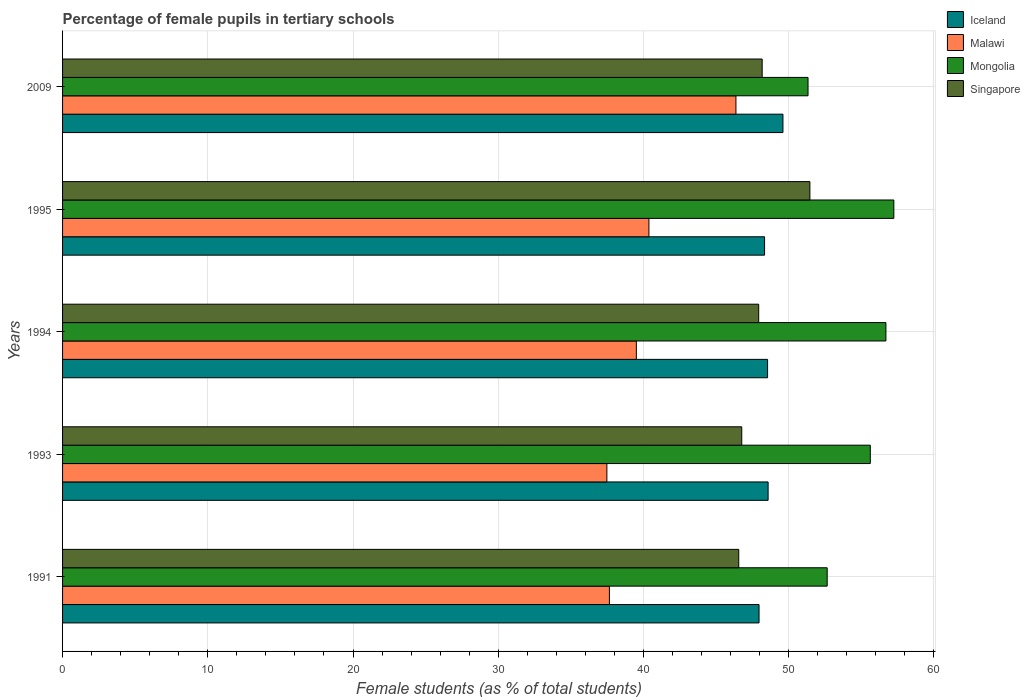How many bars are there on the 2nd tick from the top?
Provide a succinct answer. 4. What is the label of the 4th group of bars from the top?
Your response must be concise. 1993. What is the percentage of female pupils in tertiary schools in Malawi in 2009?
Make the answer very short. 46.37. Across all years, what is the maximum percentage of female pupils in tertiary schools in Mongolia?
Keep it short and to the point. 57.25. Across all years, what is the minimum percentage of female pupils in tertiary schools in Malawi?
Your response must be concise. 37.48. In which year was the percentage of female pupils in tertiary schools in Iceland minimum?
Your answer should be compact. 1991. What is the total percentage of female pupils in tertiary schools in Malawi in the graph?
Your answer should be very brief. 201.4. What is the difference between the percentage of female pupils in tertiary schools in Singapore in 1994 and that in 1995?
Your answer should be very brief. -3.53. What is the difference between the percentage of female pupils in tertiary schools in Malawi in 1994 and the percentage of female pupils in tertiary schools in Mongolia in 1993?
Give a very brief answer. -16.11. What is the average percentage of female pupils in tertiary schools in Iceland per year?
Your answer should be very brief. 48.61. In the year 1993, what is the difference between the percentage of female pupils in tertiary schools in Singapore and percentage of female pupils in tertiary schools in Iceland?
Your response must be concise. -1.81. In how many years, is the percentage of female pupils in tertiary schools in Iceland greater than 14 %?
Your answer should be compact. 5. What is the ratio of the percentage of female pupils in tertiary schools in Mongolia in 1993 to that in 1994?
Make the answer very short. 0.98. What is the difference between the highest and the second highest percentage of female pupils in tertiary schools in Iceland?
Provide a short and direct response. 1.02. What is the difference between the highest and the lowest percentage of female pupils in tertiary schools in Malawi?
Your answer should be very brief. 8.89. Is the sum of the percentage of female pupils in tertiary schools in Singapore in 1993 and 1995 greater than the maximum percentage of female pupils in tertiary schools in Iceland across all years?
Give a very brief answer. Yes. Is it the case that in every year, the sum of the percentage of female pupils in tertiary schools in Singapore and percentage of female pupils in tertiary schools in Mongolia is greater than the sum of percentage of female pupils in tertiary schools in Iceland and percentage of female pupils in tertiary schools in Malawi?
Give a very brief answer. Yes. What does the 1st bar from the top in 2009 represents?
Make the answer very short. Singapore. What does the 1st bar from the bottom in 1993 represents?
Give a very brief answer. Iceland. Is it the case that in every year, the sum of the percentage of female pupils in tertiary schools in Iceland and percentage of female pupils in tertiary schools in Mongolia is greater than the percentage of female pupils in tertiary schools in Malawi?
Make the answer very short. Yes. How many years are there in the graph?
Provide a short and direct response. 5. Does the graph contain grids?
Make the answer very short. Yes. Where does the legend appear in the graph?
Give a very brief answer. Top right. How many legend labels are there?
Make the answer very short. 4. How are the legend labels stacked?
Provide a succinct answer. Vertical. What is the title of the graph?
Your response must be concise. Percentage of female pupils in tertiary schools. What is the label or title of the X-axis?
Give a very brief answer. Female students (as % of total students). What is the Female students (as % of total students) of Iceland in 1991?
Keep it short and to the point. 47.96. What is the Female students (as % of total students) in Malawi in 1991?
Give a very brief answer. 37.66. What is the Female students (as % of total students) of Mongolia in 1991?
Your response must be concise. 52.66. What is the Female students (as % of total students) of Singapore in 1991?
Your answer should be very brief. 46.56. What is the Female students (as % of total students) in Iceland in 1993?
Keep it short and to the point. 48.59. What is the Female students (as % of total students) in Malawi in 1993?
Ensure brevity in your answer.  37.48. What is the Female students (as % of total students) in Mongolia in 1993?
Make the answer very short. 55.62. What is the Female students (as % of total students) of Singapore in 1993?
Your answer should be compact. 46.77. What is the Female students (as % of total students) in Iceland in 1994?
Give a very brief answer. 48.55. What is the Female students (as % of total students) in Malawi in 1994?
Keep it short and to the point. 39.51. What is the Female students (as % of total students) of Mongolia in 1994?
Offer a terse response. 56.7. What is the Female students (as % of total students) of Singapore in 1994?
Make the answer very short. 47.94. What is the Female students (as % of total students) of Iceland in 1995?
Your answer should be compact. 48.34. What is the Female students (as % of total students) in Malawi in 1995?
Make the answer very short. 40.38. What is the Female students (as % of total students) in Mongolia in 1995?
Give a very brief answer. 57.25. What is the Female students (as % of total students) in Singapore in 1995?
Keep it short and to the point. 51.46. What is the Female students (as % of total students) in Iceland in 2009?
Your response must be concise. 49.61. What is the Female students (as % of total students) in Malawi in 2009?
Your answer should be compact. 46.37. What is the Female students (as % of total students) in Mongolia in 2009?
Ensure brevity in your answer.  51.34. What is the Female students (as % of total students) in Singapore in 2009?
Provide a succinct answer. 48.18. Across all years, what is the maximum Female students (as % of total students) of Iceland?
Provide a succinct answer. 49.61. Across all years, what is the maximum Female students (as % of total students) in Malawi?
Give a very brief answer. 46.37. Across all years, what is the maximum Female students (as % of total students) in Mongolia?
Your response must be concise. 57.25. Across all years, what is the maximum Female students (as % of total students) in Singapore?
Your response must be concise. 51.46. Across all years, what is the minimum Female students (as % of total students) of Iceland?
Make the answer very short. 47.96. Across all years, what is the minimum Female students (as % of total students) in Malawi?
Your answer should be compact. 37.48. Across all years, what is the minimum Female students (as % of total students) of Mongolia?
Provide a short and direct response. 51.34. Across all years, what is the minimum Female students (as % of total students) in Singapore?
Offer a terse response. 46.56. What is the total Female students (as % of total students) in Iceland in the graph?
Offer a very short reply. 243.05. What is the total Female students (as % of total students) of Malawi in the graph?
Your response must be concise. 201.4. What is the total Female students (as % of total students) of Mongolia in the graph?
Your answer should be compact. 273.56. What is the total Female students (as % of total students) in Singapore in the graph?
Your answer should be very brief. 240.92. What is the difference between the Female students (as % of total students) of Iceland in 1991 and that in 1993?
Offer a very short reply. -0.62. What is the difference between the Female students (as % of total students) of Malawi in 1991 and that in 1993?
Provide a succinct answer. 0.17. What is the difference between the Female students (as % of total students) of Mongolia in 1991 and that in 1993?
Your answer should be compact. -2.97. What is the difference between the Female students (as % of total students) in Singapore in 1991 and that in 1993?
Your answer should be very brief. -0.21. What is the difference between the Female students (as % of total students) in Iceland in 1991 and that in 1994?
Your answer should be compact. -0.59. What is the difference between the Female students (as % of total students) of Malawi in 1991 and that in 1994?
Keep it short and to the point. -1.85. What is the difference between the Female students (as % of total students) in Mongolia in 1991 and that in 1994?
Give a very brief answer. -4.04. What is the difference between the Female students (as % of total students) in Singapore in 1991 and that in 1994?
Keep it short and to the point. -1.37. What is the difference between the Female students (as % of total students) of Iceland in 1991 and that in 1995?
Give a very brief answer. -0.38. What is the difference between the Female students (as % of total students) of Malawi in 1991 and that in 1995?
Your answer should be compact. -2.72. What is the difference between the Female students (as % of total students) in Mongolia in 1991 and that in 1995?
Offer a terse response. -4.59. What is the difference between the Female students (as % of total students) of Singapore in 1991 and that in 1995?
Your response must be concise. -4.9. What is the difference between the Female students (as % of total students) in Iceland in 1991 and that in 2009?
Offer a very short reply. -1.65. What is the difference between the Female students (as % of total students) of Malawi in 1991 and that in 2009?
Your response must be concise. -8.71. What is the difference between the Female students (as % of total students) in Mongolia in 1991 and that in 2009?
Keep it short and to the point. 1.32. What is the difference between the Female students (as % of total students) of Singapore in 1991 and that in 2009?
Give a very brief answer. -1.61. What is the difference between the Female students (as % of total students) in Iceland in 1993 and that in 1994?
Keep it short and to the point. 0.04. What is the difference between the Female students (as % of total students) in Malawi in 1993 and that in 1994?
Provide a succinct answer. -2.03. What is the difference between the Female students (as % of total students) in Mongolia in 1993 and that in 1994?
Provide a short and direct response. -1.08. What is the difference between the Female students (as % of total students) in Singapore in 1993 and that in 1994?
Your answer should be very brief. -1.17. What is the difference between the Female students (as % of total students) of Iceland in 1993 and that in 1995?
Ensure brevity in your answer.  0.24. What is the difference between the Female students (as % of total students) of Malawi in 1993 and that in 1995?
Offer a terse response. -2.9. What is the difference between the Female students (as % of total students) of Mongolia in 1993 and that in 1995?
Offer a very short reply. -1.62. What is the difference between the Female students (as % of total students) of Singapore in 1993 and that in 1995?
Your answer should be very brief. -4.69. What is the difference between the Female students (as % of total students) in Iceland in 1993 and that in 2009?
Make the answer very short. -1.02. What is the difference between the Female students (as % of total students) in Malawi in 1993 and that in 2009?
Your answer should be compact. -8.89. What is the difference between the Female students (as % of total students) in Mongolia in 1993 and that in 2009?
Offer a terse response. 4.29. What is the difference between the Female students (as % of total students) in Singapore in 1993 and that in 2009?
Make the answer very short. -1.41. What is the difference between the Female students (as % of total students) of Iceland in 1994 and that in 1995?
Provide a succinct answer. 0.21. What is the difference between the Female students (as % of total students) of Malawi in 1994 and that in 1995?
Your answer should be very brief. -0.87. What is the difference between the Female students (as % of total students) of Mongolia in 1994 and that in 1995?
Provide a succinct answer. -0.55. What is the difference between the Female students (as % of total students) of Singapore in 1994 and that in 1995?
Ensure brevity in your answer.  -3.53. What is the difference between the Female students (as % of total students) of Iceland in 1994 and that in 2009?
Offer a terse response. -1.06. What is the difference between the Female students (as % of total students) of Malawi in 1994 and that in 2009?
Ensure brevity in your answer.  -6.86. What is the difference between the Female students (as % of total students) of Mongolia in 1994 and that in 2009?
Ensure brevity in your answer.  5.36. What is the difference between the Female students (as % of total students) of Singapore in 1994 and that in 2009?
Provide a succinct answer. -0.24. What is the difference between the Female students (as % of total students) in Iceland in 1995 and that in 2009?
Your answer should be very brief. -1.27. What is the difference between the Female students (as % of total students) of Malawi in 1995 and that in 2009?
Your response must be concise. -5.99. What is the difference between the Female students (as % of total students) of Mongolia in 1995 and that in 2009?
Provide a short and direct response. 5.91. What is the difference between the Female students (as % of total students) of Singapore in 1995 and that in 2009?
Ensure brevity in your answer.  3.29. What is the difference between the Female students (as % of total students) of Iceland in 1991 and the Female students (as % of total students) of Malawi in 1993?
Provide a short and direct response. 10.48. What is the difference between the Female students (as % of total students) of Iceland in 1991 and the Female students (as % of total students) of Mongolia in 1993?
Offer a terse response. -7.66. What is the difference between the Female students (as % of total students) in Iceland in 1991 and the Female students (as % of total students) in Singapore in 1993?
Provide a succinct answer. 1.19. What is the difference between the Female students (as % of total students) of Malawi in 1991 and the Female students (as % of total students) of Mongolia in 1993?
Offer a terse response. -17.97. What is the difference between the Female students (as % of total students) of Malawi in 1991 and the Female students (as % of total students) of Singapore in 1993?
Give a very brief answer. -9.11. What is the difference between the Female students (as % of total students) of Mongolia in 1991 and the Female students (as % of total students) of Singapore in 1993?
Provide a short and direct response. 5.88. What is the difference between the Female students (as % of total students) of Iceland in 1991 and the Female students (as % of total students) of Malawi in 1994?
Your answer should be compact. 8.45. What is the difference between the Female students (as % of total students) in Iceland in 1991 and the Female students (as % of total students) in Mongolia in 1994?
Make the answer very short. -8.74. What is the difference between the Female students (as % of total students) in Iceland in 1991 and the Female students (as % of total students) in Singapore in 1994?
Make the answer very short. 0.02. What is the difference between the Female students (as % of total students) in Malawi in 1991 and the Female students (as % of total students) in Mongolia in 1994?
Your answer should be very brief. -19.04. What is the difference between the Female students (as % of total students) of Malawi in 1991 and the Female students (as % of total students) of Singapore in 1994?
Your answer should be very brief. -10.28. What is the difference between the Female students (as % of total students) of Mongolia in 1991 and the Female students (as % of total students) of Singapore in 1994?
Make the answer very short. 4.72. What is the difference between the Female students (as % of total students) of Iceland in 1991 and the Female students (as % of total students) of Malawi in 1995?
Provide a short and direct response. 7.58. What is the difference between the Female students (as % of total students) in Iceland in 1991 and the Female students (as % of total students) in Mongolia in 1995?
Ensure brevity in your answer.  -9.28. What is the difference between the Female students (as % of total students) in Iceland in 1991 and the Female students (as % of total students) in Singapore in 1995?
Offer a very short reply. -3.5. What is the difference between the Female students (as % of total students) of Malawi in 1991 and the Female students (as % of total students) of Mongolia in 1995?
Ensure brevity in your answer.  -19.59. What is the difference between the Female students (as % of total students) of Malawi in 1991 and the Female students (as % of total students) of Singapore in 1995?
Give a very brief answer. -13.81. What is the difference between the Female students (as % of total students) of Mongolia in 1991 and the Female students (as % of total students) of Singapore in 1995?
Provide a short and direct response. 1.19. What is the difference between the Female students (as % of total students) in Iceland in 1991 and the Female students (as % of total students) in Malawi in 2009?
Ensure brevity in your answer.  1.59. What is the difference between the Female students (as % of total students) in Iceland in 1991 and the Female students (as % of total students) in Mongolia in 2009?
Make the answer very short. -3.37. What is the difference between the Female students (as % of total students) in Iceland in 1991 and the Female students (as % of total students) in Singapore in 2009?
Provide a succinct answer. -0.22. What is the difference between the Female students (as % of total students) of Malawi in 1991 and the Female students (as % of total students) of Mongolia in 2009?
Your response must be concise. -13.68. What is the difference between the Female students (as % of total students) of Malawi in 1991 and the Female students (as % of total students) of Singapore in 2009?
Your answer should be compact. -10.52. What is the difference between the Female students (as % of total students) of Mongolia in 1991 and the Female students (as % of total students) of Singapore in 2009?
Make the answer very short. 4.48. What is the difference between the Female students (as % of total students) in Iceland in 1993 and the Female students (as % of total students) in Malawi in 1994?
Ensure brevity in your answer.  9.07. What is the difference between the Female students (as % of total students) in Iceland in 1993 and the Female students (as % of total students) in Mongolia in 1994?
Make the answer very short. -8.11. What is the difference between the Female students (as % of total students) of Iceland in 1993 and the Female students (as % of total students) of Singapore in 1994?
Give a very brief answer. 0.65. What is the difference between the Female students (as % of total students) in Malawi in 1993 and the Female students (as % of total students) in Mongolia in 1994?
Your answer should be compact. -19.22. What is the difference between the Female students (as % of total students) of Malawi in 1993 and the Female students (as % of total students) of Singapore in 1994?
Offer a very short reply. -10.46. What is the difference between the Female students (as % of total students) in Mongolia in 1993 and the Female students (as % of total students) in Singapore in 1994?
Your answer should be compact. 7.68. What is the difference between the Female students (as % of total students) in Iceland in 1993 and the Female students (as % of total students) in Malawi in 1995?
Ensure brevity in your answer.  8.21. What is the difference between the Female students (as % of total students) in Iceland in 1993 and the Female students (as % of total students) in Mongolia in 1995?
Your response must be concise. -8.66. What is the difference between the Female students (as % of total students) of Iceland in 1993 and the Female students (as % of total students) of Singapore in 1995?
Your response must be concise. -2.88. What is the difference between the Female students (as % of total students) in Malawi in 1993 and the Female students (as % of total students) in Mongolia in 1995?
Ensure brevity in your answer.  -19.76. What is the difference between the Female students (as % of total students) of Malawi in 1993 and the Female students (as % of total students) of Singapore in 1995?
Ensure brevity in your answer.  -13.98. What is the difference between the Female students (as % of total students) in Mongolia in 1993 and the Female students (as % of total students) in Singapore in 1995?
Your answer should be compact. 4.16. What is the difference between the Female students (as % of total students) of Iceland in 1993 and the Female students (as % of total students) of Malawi in 2009?
Ensure brevity in your answer.  2.21. What is the difference between the Female students (as % of total students) of Iceland in 1993 and the Female students (as % of total students) of Mongolia in 2009?
Make the answer very short. -2.75. What is the difference between the Female students (as % of total students) in Iceland in 1993 and the Female students (as % of total students) in Singapore in 2009?
Your answer should be very brief. 0.41. What is the difference between the Female students (as % of total students) in Malawi in 1993 and the Female students (as % of total students) in Mongolia in 2009?
Offer a terse response. -13.85. What is the difference between the Female students (as % of total students) of Malawi in 1993 and the Female students (as % of total students) of Singapore in 2009?
Provide a short and direct response. -10.69. What is the difference between the Female students (as % of total students) of Mongolia in 1993 and the Female students (as % of total students) of Singapore in 2009?
Keep it short and to the point. 7.45. What is the difference between the Female students (as % of total students) in Iceland in 1994 and the Female students (as % of total students) in Malawi in 1995?
Provide a short and direct response. 8.17. What is the difference between the Female students (as % of total students) of Iceland in 1994 and the Female students (as % of total students) of Mongolia in 1995?
Ensure brevity in your answer.  -8.7. What is the difference between the Female students (as % of total students) of Iceland in 1994 and the Female students (as % of total students) of Singapore in 1995?
Offer a terse response. -2.91. What is the difference between the Female students (as % of total students) in Malawi in 1994 and the Female students (as % of total students) in Mongolia in 1995?
Give a very brief answer. -17.73. What is the difference between the Female students (as % of total students) of Malawi in 1994 and the Female students (as % of total students) of Singapore in 1995?
Provide a succinct answer. -11.95. What is the difference between the Female students (as % of total students) in Mongolia in 1994 and the Female students (as % of total students) in Singapore in 1995?
Offer a very short reply. 5.24. What is the difference between the Female students (as % of total students) in Iceland in 1994 and the Female students (as % of total students) in Malawi in 2009?
Provide a short and direct response. 2.18. What is the difference between the Female students (as % of total students) in Iceland in 1994 and the Female students (as % of total students) in Mongolia in 2009?
Offer a very short reply. -2.79. What is the difference between the Female students (as % of total students) of Iceland in 1994 and the Female students (as % of total students) of Singapore in 2009?
Keep it short and to the point. 0.37. What is the difference between the Female students (as % of total students) of Malawi in 1994 and the Female students (as % of total students) of Mongolia in 2009?
Ensure brevity in your answer.  -11.82. What is the difference between the Female students (as % of total students) of Malawi in 1994 and the Female students (as % of total students) of Singapore in 2009?
Your answer should be very brief. -8.67. What is the difference between the Female students (as % of total students) in Mongolia in 1994 and the Female students (as % of total students) in Singapore in 2009?
Offer a very short reply. 8.52. What is the difference between the Female students (as % of total students) in Iceland in 1995 and the Female students (as % of total students) in Malawi in 2009?
Your answer should be compact. 1.97. What is the difference between the Female students (as % of total students) in Iceland in 1995 and the Female students (as % of total students) in Mongolia in 2009?
Offer a very short reply. -2.99. What is the difference between the Female students (as % of total students) in Iceland in 1995 and the Female students (as % of total students) in Singapore in 2009?
Ensure brevity in your answer.  0.16. What is the difference between the Female students (as % of total students) in Malawi in 1995 and the Female students (as % of total students) in Mongolia in 2009?
Ensure brevity in your answer.  -10.96. What is the difference between the Female students (as % of total students) in Malawi in 1995 and the Female students (as % of total students) in Singapore in 2009?
Make the answer very short. -7.8. What is the difference between the Female students (as % of total students) in Mongolia in 1995 and the Female students (as % of total students) in Singapore in 2009?
Offer a terse response. 9.07. What is the average Female students (as % of total students) in Iceland per year?
Keep it short and to the point. 48.61. What is the average Female students (as % of total students) in Malawi per year?
Offer a terse response. 40.28. What is the average Female students (as % of total students) of Mongolia per year?
Your answer should be very brief. 54.71. What is the average Female students (as % of total students) of Singapore per year?
Ensure brevity in your answer.  48.18. In the year 1991, what is the difference between the Female students (as % of total students) in Iceland and Female students (as % of total students) in Malawi?
Make the answer very short. 10.3. In the year 1991, what is the difference between the Female students (as % of total students) in Iceland and Female students (as % of total students) in Mongolia?
Give a very brief answer. -4.69. In the year 1991, what is the difference between the Female students (as % of total students) in Iceland and Female students (as % of total students) in Singapore?
Provide a succinct answer. 1.4. In the year 1991, what is the difference between the Female students (as % of total students) in Malawi and Female students (as % of total students) in Mongolia?
Give a very brief answer. -15. In the year 1991, what is the difference between the Female students (as % of total students) of Malawi and Female students (as % of total students) of Singapore?
Provide a short and direct response. -8.91. In the year 1991, what is the difference between the Female students (as % of total students) of Mongolia and Female students (as % of total students) of Singapore?
Provide a succinct answer. 6.09. In the year 1993, what is the difference between the Female students (as % of total students) of Iceland and Female students (as % of total students) of Malawi?
Your response must be concise. 11.1. In the year 1993, what is the difference between the Female students (as % of total students) in Iceland and Female students (as % of total students) in Mongolia?
Provide a succinct answer. -7.04. In the year 1993, what is the difference between the Female students (as % of total students) of Iceland and Female students (as % of total students) of Singapore?
Your answer should be compact. 1.81. In the year 1993, what is the difference between the Female students (as % of total students) of Malawi and Female students (as % of total students) of Mongolia?
Keep it short and to the point. -18.14. In the year 1993, what is the difference between the Female students (as % of total students) of Malawi and Female students (as % of total students) of Singapore?
Ensure brevity in your answer.  -9.29. In the year 1993, what is the difference between the Female students (as % of total students) of Mongolia and Female students (as % of total students) of Singapore?
Give a very brief answer. 8.85. In the year 1994, what is the difference between the Female students (as % of total students) of Iceland and Female students (as % of total students) of Malawi?
Your answer should be compact. 9.04. In the year 1994, what is the difference between the Female students (as % of total students) of Iceland and Female students (as % of total students) of Mongolia?
Ensure brevity in your answer.  -8.15. In the year 1994, what is the difference between the Female students (as % of total students) in Iceland and Female students (as % of total students) in Singapore?
Offer a terse response. 0.61. In the year 1994, what is the difference between the Female students (as % of total students) in Malawi and Female students (as % of total students) in Mongolia?
Your answer should be compact. -17.19. In the year 1994, what is the difference between the Female students (as % of total students) in Malawi and Female students (as % of total students) in Singapore?
Offer a terse response. -8.43. In the year 1994, what is the difference between the Female students (as % of total students) in Mongolia and Female students (as % of total students) in Singapore?
Your answer should be compact. 8.76. In the year 1995, what is the difference between the Female students (as % of total students) in Iceland and Female students (as % of total students) in Malawi?
Ensure brevity in your answer.  7.96. In the year 1995, what is the difference between the Female students (as % of total students) of Iceland and Female students (as % of total students) of Mongolia?
Provide a short and direct response. -8.9. In the year 1995, what is the difference between the Female students (as % of total students) in Iceland and Female students (as % of total students) in Singapore?
Give a very brief answer. -3.12. In the year 1995, what is the difference between the Female students (as % of total students) of Malawi and Female students (as % of total students) of Mongolia?
Offer a terse response. -16.87. In the year 1995, what is the difference between the Female students (as % of total students) of Malawi and Female students (as % of total students) of Singapore?
Your answer should be very brief. -11.09. In the year 1995, what is the difference between the Female students (as % of total students) of Mongolia and Female students (as % of total students) of Singapore?
Offer a terse response. 5.78. In the year 2009, what is the difference between the Female students (as % of total students) in Iceland and Female students (as % of total students) in Malawi?
Your response must be concise. 3.24. In the year 2009, what is the difference between the Female students (as % of total students) in Iceland and Female students (as % of total students) in Mongolia?
Offer a very short reply. -1.73. In the year 2009, what is the difference between the Female students (as % of total students) of Iceland and Female students (as % of total students) of Singapore?
Your response must be concise. 1.43. In the year 2009, what is the difference between the Female students (as % of total students) of Malawi and Female students (as % of total students) of Mongolia?
Your response must be concise. -4.96. In the year 2009, what is the difference between the Female students (as % of total students) of Malawi and Female students (as % of total students) of Singapore?
Keep it short and to the point. -1.81. In the year 2009, what is the difference between the Female students (as % of total students) of Mongolia and Female students (as % of total students) of Singapore?
Offer a terse response. 3.16. What is the ratio of the Female students (as % of total students) of Iceland in 1991 to that in 1993?
Keep it short and to the point. 0.99. What is the ratio of the Female students (as % of total students) in Mongolia in 1991 to that in 1993?
Offer a terse response. 0.95. What is the ratio of the Female students (as % of total students) in Singapore in 1991 to that in 1993?
Your answer should be compact. 1. What is the ratio of the Female students (as % of total students) of Iceland in 1991 to that in 1994?
Provide a succinct answer. 0.99. What is the ratio of the Female students (as % of total students) in Malawi in 1991 to that in 1994?
Provide a short and direct response. 0.95. What is the ratio of the Female students (as % of total students) of Mongolia in 1991 to that in 1994?
Provide a succinct answer. 0.93. What is the ratio of the Female students (as % of total students) of Singapore in 1991 to that in 1994?
Keep it short and to the point. 0.97. What is the ratio of the Female students (as % of total students) in Iceland in 1991 to that in 1995?
Provide a short and direct response. 0.99. What is the ratio of the Female students (as % of total students) in Malawi in 1991 to that in 1995?
Ensure brevity in your answer.  0.93. What is the ratio of the Female students (as % of total students) of Mongolia in 1991 to that in 1995?
Your response must be concise. 0.92. What is the ratio of the Female students (as % of total students) in Singapore in 1991 to that in 1995?
Ensure brevity in your answer.  0.9. What is the ratio of the Female students (as % of total students) of Iceland in 1991 to that in 2009?
Provide a short and direct response. 0.97. What is the ratio of the Female students (as % of total students) in Malawi in 1991 to that in 2009?
Provide a succinct answer. 0.81. What is the ratio of the Female students (as % of total students) in Mongolia in 1991 to that in 2009?
Provide a short and direct response. 1.03. What is the ratio of the Female students (as % of total students) of Singapore in 1991 to that in 2009?
Provide a short and direct response. 0.97. What is the ratio of the Female students (as % of total students) of Malawi in 1993 to that in 1994?
Your answer should be compact. 0.95. What is the ratio of the Female students (as % of total students) in Mongolia in 1993 to that in 1994?
Ensure brevity in your answer.  0.98. What is the ratio of the Female students (as % of total students) of Singapore in 1993 to that in 1994?
Give a very brief answer. 0.98. What is the ratio of the Female students (as % of total students) of Malawi in 1993 to that in 1995?
Make the answer very short. 0.93. What is the ratio of the Female students (as % of total students) of Mongolia in 1993 to that in 1995?
Provide a short and direct response. 0.97. What is the ratio of the Female students (as % of total students) of Singapore in 1993 to that in 1995?
Offer a very short reply. 0.91. What is the ratio of the Female students (as % of total students) in Iceland in 1993 to that in 2009?
Provide a short and direct response. 0.98. What is the ratio of the Female students (as % of total students) of Malawi in 1993 to that in 2009?
Offer a very short reply. 0.81. What is the ratio of the Female students (as % of total students) of Mongolia in 1993 to that in 2009?
Your answer should be very brief. 1.08. What is the ratio of the Female students (as % of total students) in Singapore in 1993 to that in 2009?
Your answer should be very brief. 0.97. What is the ratio of the Female students (as % of total students) in Malawi in 1994 to that in 1995?
Keep it short and to the point. 0.98. What is the ratio of the Female students (as % of total students) in Singapore in 1994 to that in 1995?
Give a very brief answer. 0.93. What is the ratio of the Female students (as % of total students) of Iceland in 1994 to that in 2009?
Ensure brevity in your answer.  0.98. What is the ratio of the Female students (as % of total students) of Malawi in 1994 to that in 2009?
Offer a very short reply. 0.85. What is the ratio of the Female students (as % of total students) of Mongolia in 1994 to that in 2009?
Offer a terse response. 1.1. What is the ratio of the Female students (as % of total students) in Iceland in 1995 to that in 2009?
Your answer should be compact. 0.97. What is the ratio of the Female students (as % of total students) of Malawi in 1995 to that in 2009?
Offer a very short reply. 0.87. What is the ratio of the Female students (as % of total students) in Mongolia in 1995 to that in 2009?
Provide a short and direct response. 1.12. What is the ratio of the Female students (as % of total students) of Singapore in 1995 to that in 2009?
Provide a succinct answer. 1.07. What is the difference between the highest and the second highest Female students (as % of total students) of Iceland?
Your answer should be very brief. 1.02. What is the difference between the highest and the second highest Female students (as % of total students) in Malawi?
Provide a short and direct response. 5.99. What is the difference between the highest and the second highest Female students (as % of total students) in Mongolia?
Ensure brevity in your answer.  0.55. What is the difference between the highest and the second highest Female students (as % of total students) of Singapore?
Ensure brevity in your answer.  3.29. What is the difference between the highest and the lowest Female students (as % of total students) of Iceland?
Your answer should be very brief. 1.65. What is the difference between the highest and the lowest Female students (as % of total students) of Malawi?
Ensure brevity in your answer.  8.89. What is the difference between the highest and the lowest Female students (as % of total students) of Mongolia?
Offer a very short reply. 5.91. What is the difference between the highest and the lowest Female students (as % of total students) of Singapore?
Ensure brevity in your answer.  4.9. 